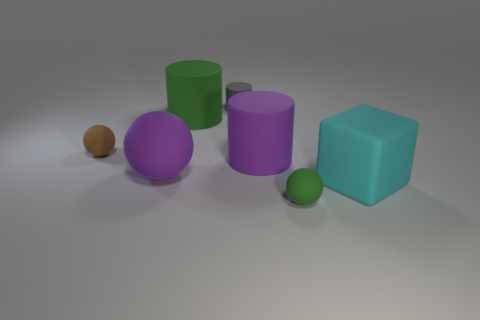Subtract all large matte cylinders. How many cylinders are left? 1 Add 3 large brown metallic cylinders. How many objects exist? 10 Subtract all blocks. How many objects are left? 6 Subtract all matte balls. Subtract all small cylinders. How many objects are left? 3 Add 1 tiny rubber spheres. How many tiny rubber spheres are left? 3 Add 2 small blue cylinders. How many small blue cylinders exist? 2 Subtract 1 green cylinders. How many objects are left? 6 